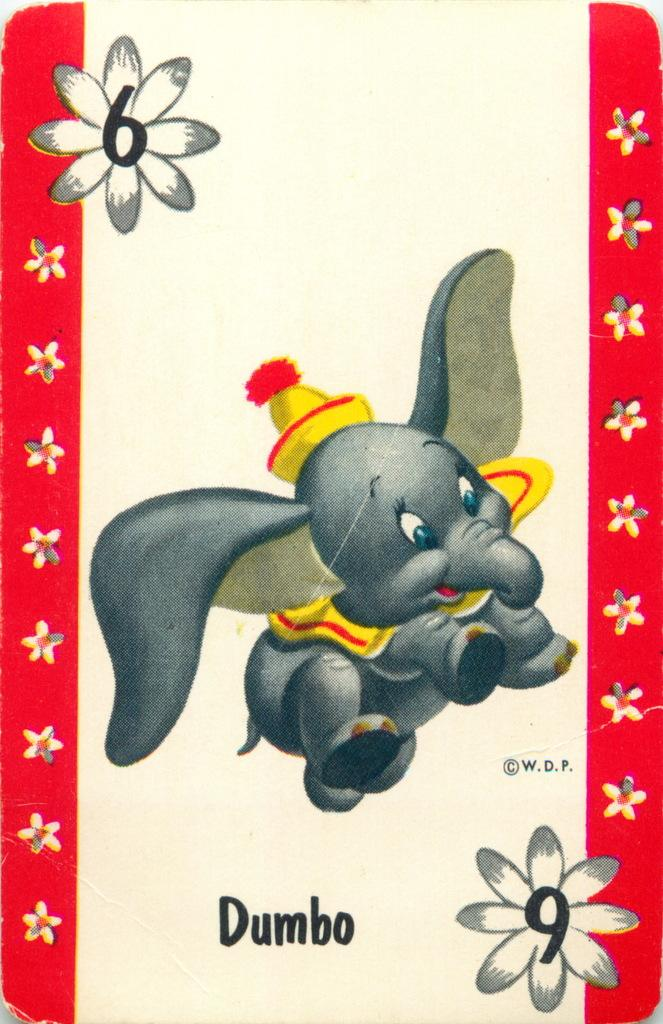What type of animal is depicted in the cartoon in the image? There is a cartoon of an elephant in the image. What other design elements can be seen in the image? There are flowers in the design of the image. Is there any text present in the image? Yes, there is text written on the image. How many seeds can be seen growing in the image? There are no seeds present in the image; it features a cartoon of an elephant and flowers in the design. 